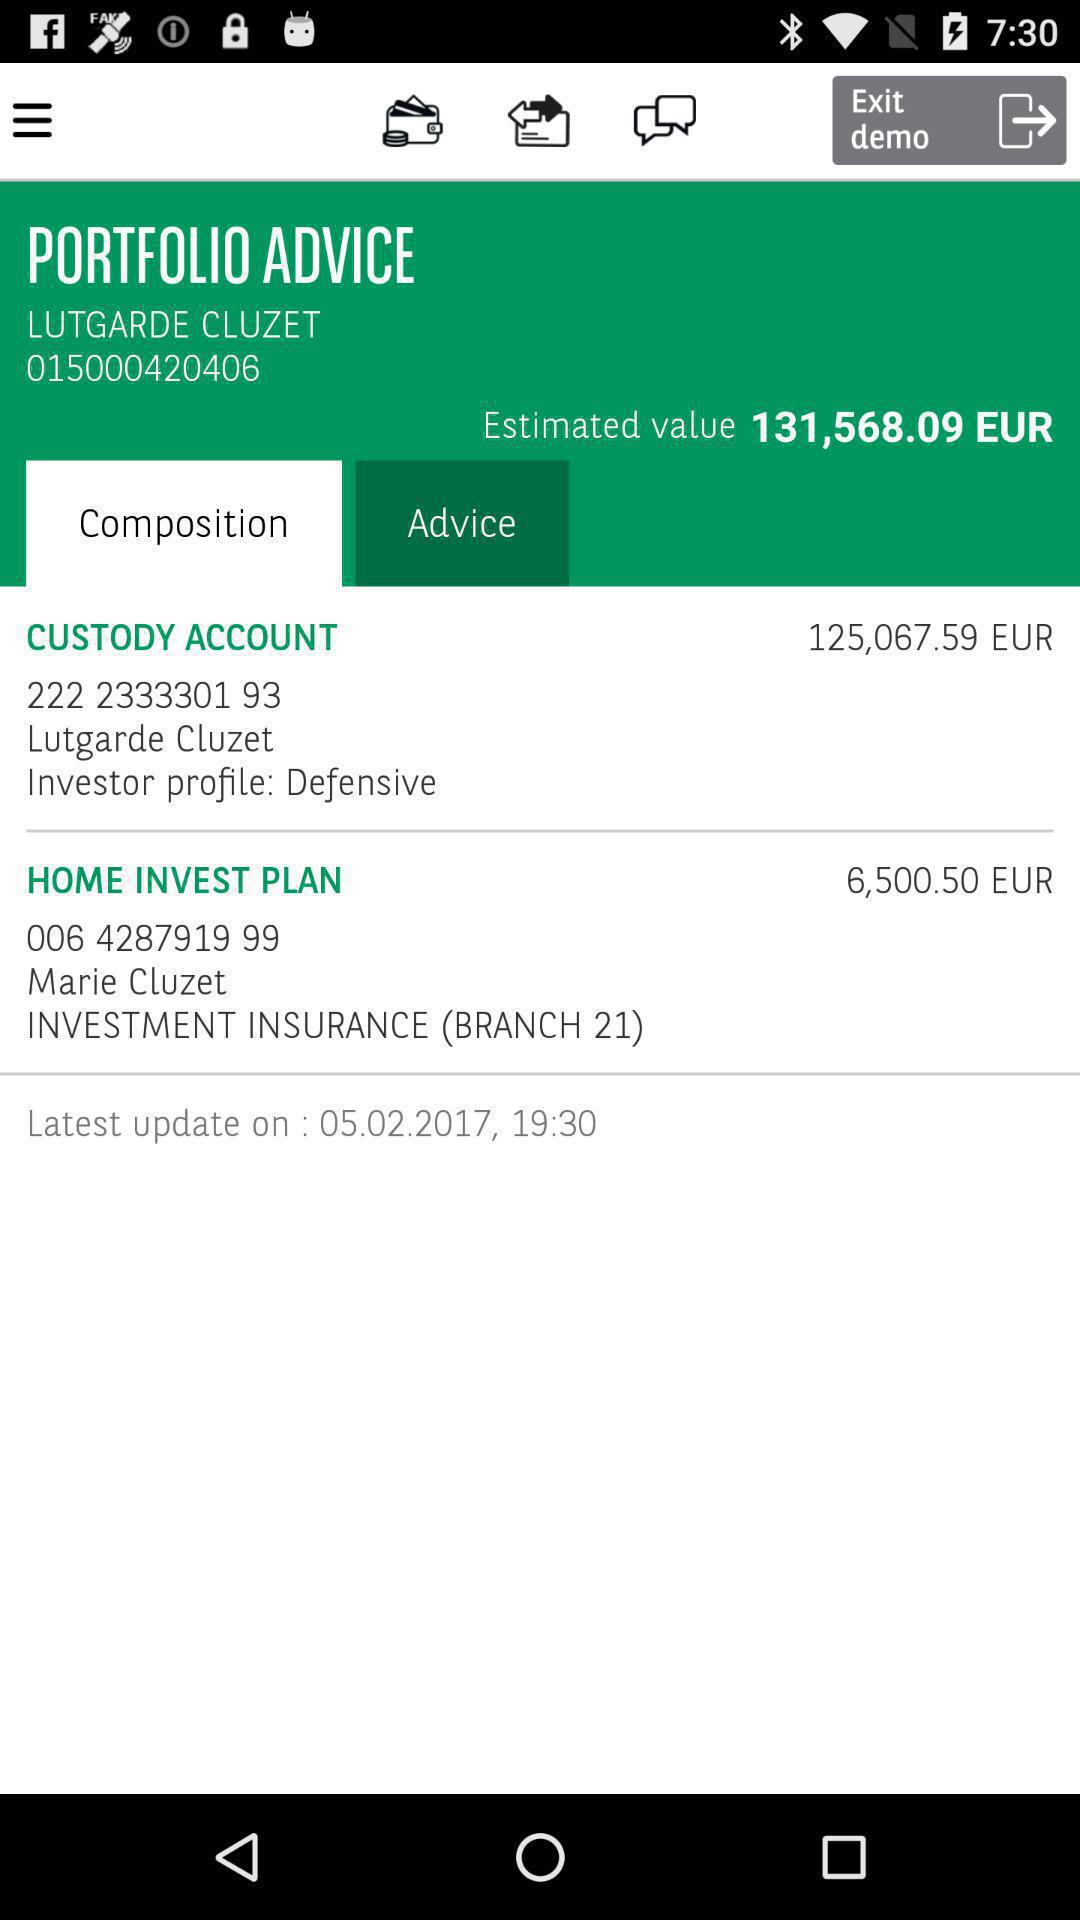How much is the estimated value in dollars?
When the provided information is insufficient, respond with <no answer>. <no answer> 